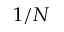<formula> <loc_0><loc_0><loc_500><loc_500>1 / N</formula> 